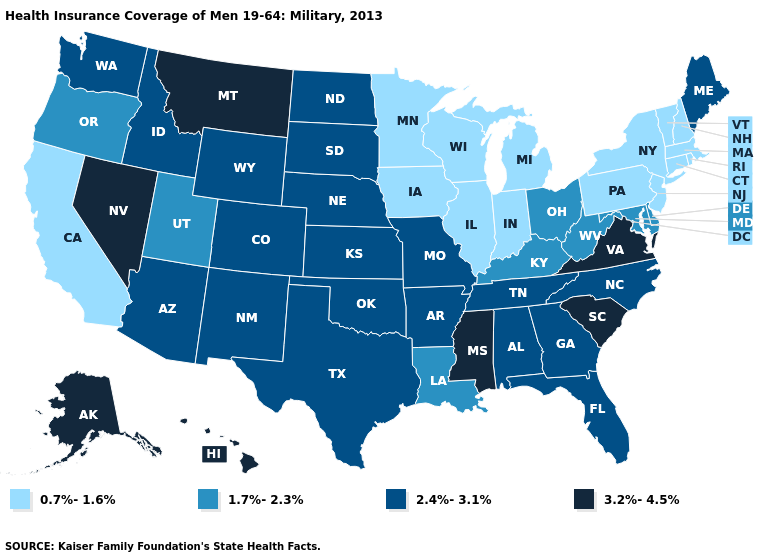What is the highest value in the USA?
Short answer required. 3.2%-4.5%. Name the states that have a value in the range 3.2%-4.5%?
Write a very short answer. Alaska, Hawaii, Mississippi, Montana, Nevada, South Carolina, Virginia. Name the states that have a value in the range 2.4%-3.1%?
Concise answer only. Alabama, Arizona, Arkansas, Colorado, Florida, Georgia, Idaho, Kansas, Maine, Missouri, Nebraska, New Mexico, North Carolina, North Dakota, Oklahoma, South Dakota, Tennessee, Texas, Washington, Wyoming. Name the states that have a value in the range 3.2%-4.5%?
Concise answer only. Alaska, Hawaii, Mississippi, Montana, Nevada, South Carolina, Virginia. Does Kentucky have a higher value than Iowa?
Be succinct. Yes. What is the value of Illinois?
Quick response, please. 0.7%-1.6%. Name the states that have a value in the range 2.4%-3.1%?
Short answer required. Alabama, Arizona, Arkansas, Colorado, Florida, Georgia, Idaho, Kansas, Maine, Missouri, Nebraska, New Mexico, North Carolina, North Dakota, Oklahoma, South Dakota, Tennessee, Texas, Washington, Wyoming. Among the states that border Maryland , does Virginia have the highest value?
Concise answer only. Yes. Name the states that have a value in the range 2.4%-3.1%?
Keep it brief. Alabama, Arizona, Arkansas, Colorado, Florida, Georgia, Idaho, Kansas, Maine, Missouri, Nebraska, New Mexico, North Carolina, North Dakota, Oklahoma, South Dakota, Tennessee, Texas, Washington, Wyoming. Name the states that have a value in the range 2.4%-3.1%?
Write a very short answer. Alabama, Arizona, Arkansas, Colorado, Florida, Georgia, Idaho, Kansas, Maine, Missouri, Nebraska, New Mexico, North Carolina, North Dakota, Oklahoma, South Dakota, Tennessee, Texas, Washington, Wyoming. Which states have the lowest value in the USA?
Short answer required. California, Connecticut, Illinois, Indiana, Iowa, Massachusetts, Michigan, Minnesota, New Hampshire, New Jersey, New York, Pennsylvania, Rhode Island, Vermont, Wisconsin. Name the states that have a value in the range 0.7%-1.6%?
Keep it brief. California, Connecticut, Illinois, Indiana, Iowa, Massachusetts, Michigan, Minnesota, New Hampshire, New Jersey, New York, Pennsylvania, Rhode Island, Vermont, Wisconsin. Among the states that border Wisconsin , which have the highest value?
Write a very short answer. Illinois, Iowa, Michigan, Minnesota. Does Iowa have the highest value in the MidWest?
Keep it brief. No. What is the lowest value in the USA?
Be succinct. 0.7%-1.6%. 